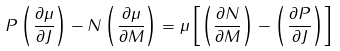<formula> <loc_0><loc_0><loc_500><loc_500>P \left ( \frac { \partial \mu } { \partial J } \right ) - N \left ( \frac { \partial \mu } { \partial M } \right ) = \mu \left [ \left ( \frac { \partial N } { \partial M } \right ) - \left ( \frac { \partial P } { \partial J } \right ) \right ]</formula> 